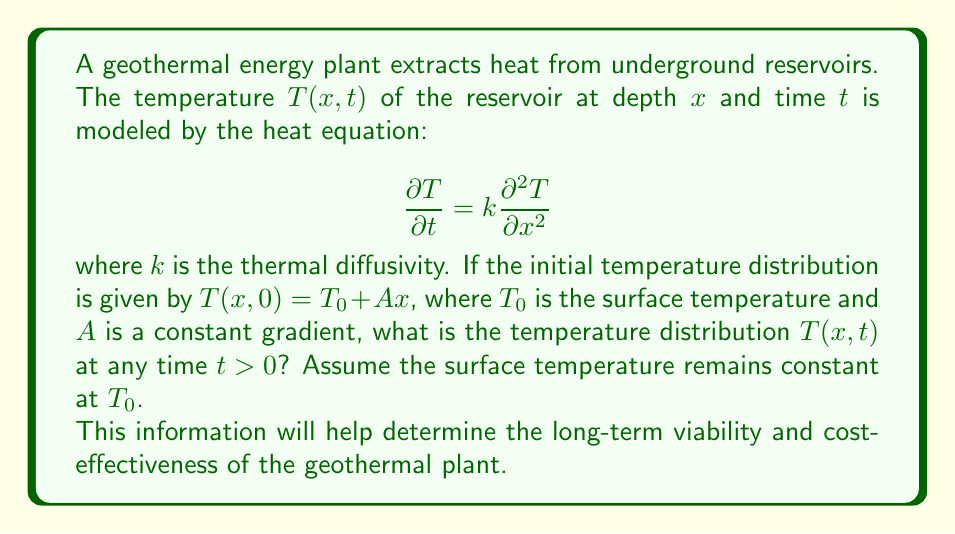Could you help me with this problem? To solve this problem, we'll follow these steps:

1) The heat equation with the given initial condition is:

   $$\frac{\partial T}{\partial t} = k\frac{\partial^2 T}{\partial x^2}$$
   $$T(x,0) = T_0 + Ax$$
   $$T(0,t) = T_0$$ (boundary condition at the surface)

2) We can guess a solution of the form:
   
   $$T(x,t) = T_0 + Ax + f(x,t)$$

   where $f(x,t)$ is a function we need to determine.

3) Substituting this into the heat equation:

   $$\frac{\partial (T_0 + Ax + f)}{\partial t} = k\frac{\partial^2 (T_0 + Ax + f)}{\partial x^2}$$

4) Simplifying:

   $$\frac{\partial f}{\partial t} = k\frac{\partial^2 f}{\partial x^2}$$

5) The initial condition for $f$ is:

   $$f(x,0) = 0$$

   And the boundary condition is:

   $$f(0,t) = 0$$

6) This is now a homogeneous heat equation with zero initial condition. The solution to this is $f(x,t) = 0$ for all $x$ and $t$.

7) Therefore, the complete solution is:

   $$T(x,t) = T_0 + Ax$$

This solution shows that the temperature distribution remains constant over time, maintaining its initial linear profile.
Answer: $T(x,t) = T_0 + Ax$ 